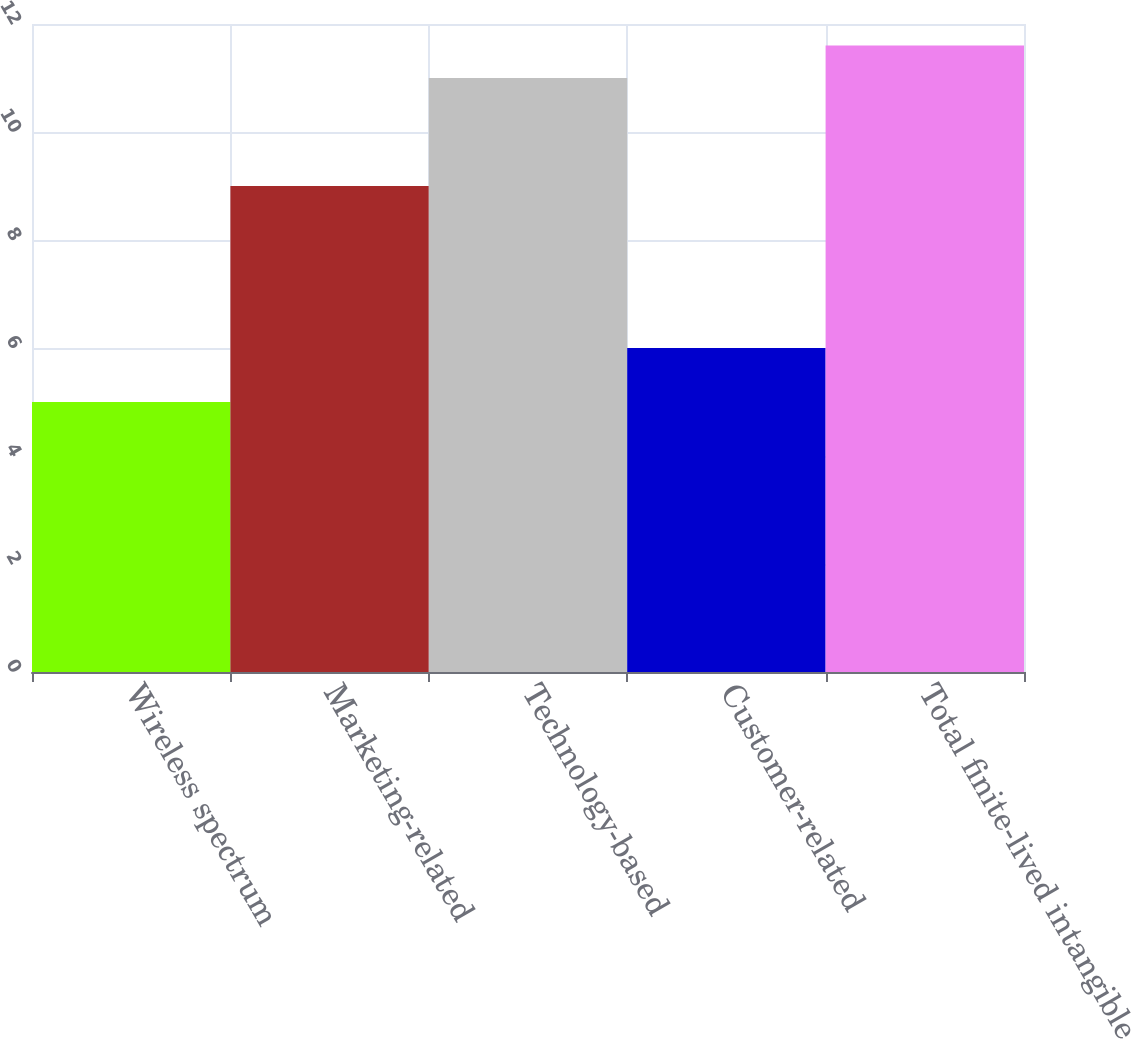Convert chart. <chart><loc_0><loc_0><loc_500><loc_500><bar_chart><fcel>Wireless spectrum<fcel>Marketing-related<fcel>Technology-based<fcel>Customer-related<fcel>Total finite-lived intangible<nl><fcel>5<fcel>9<fcel>11<fcel>6<fcel>11.6<nl></chart> 